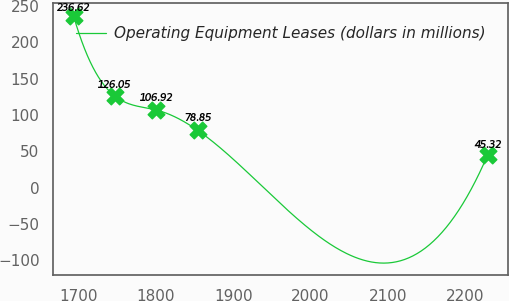<chart> <loc_0><loc_0><loc_500><loc_500><line_chart><ecel><fcel>Operating Equipment Leases (dollars in millions)<nl><fcel>1693.3<fcel>236.62<nl><fcel>1746.88<fcel>126.05<nl><fcel>1800.46<fcel>106.92<nl><fcel>1854.04<fcel>78.85<nl><fcel>2229.12<fcel>45.32<nl></chart> 